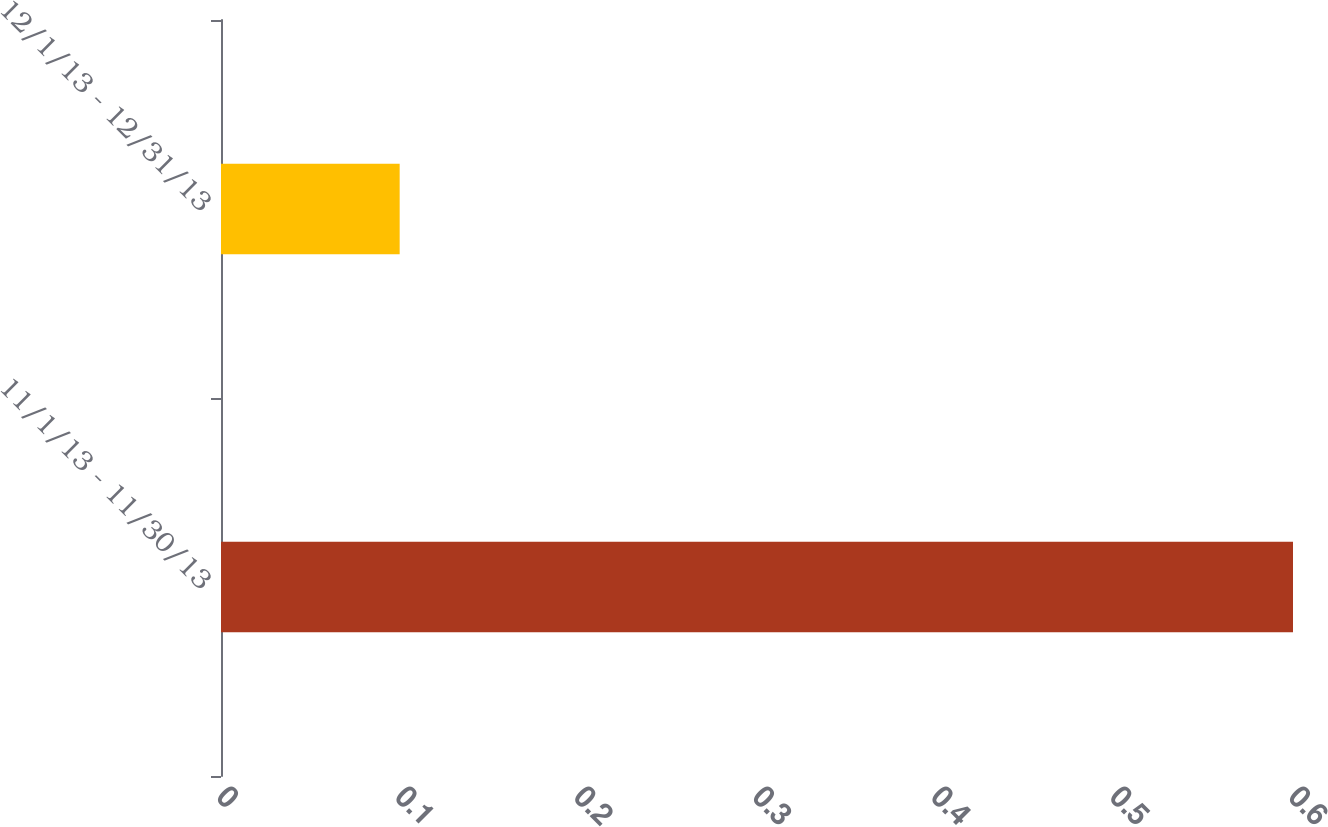Convert chart to OTSL. <chart><loc_0><loc_0><loc_500><loc_500><bar_chart><fcel>11/1/13 - 11/30/13<fcel>12/1/13 - 12/31/13<nl><fcel>0.6<fcel>0.1<nl></chart> 